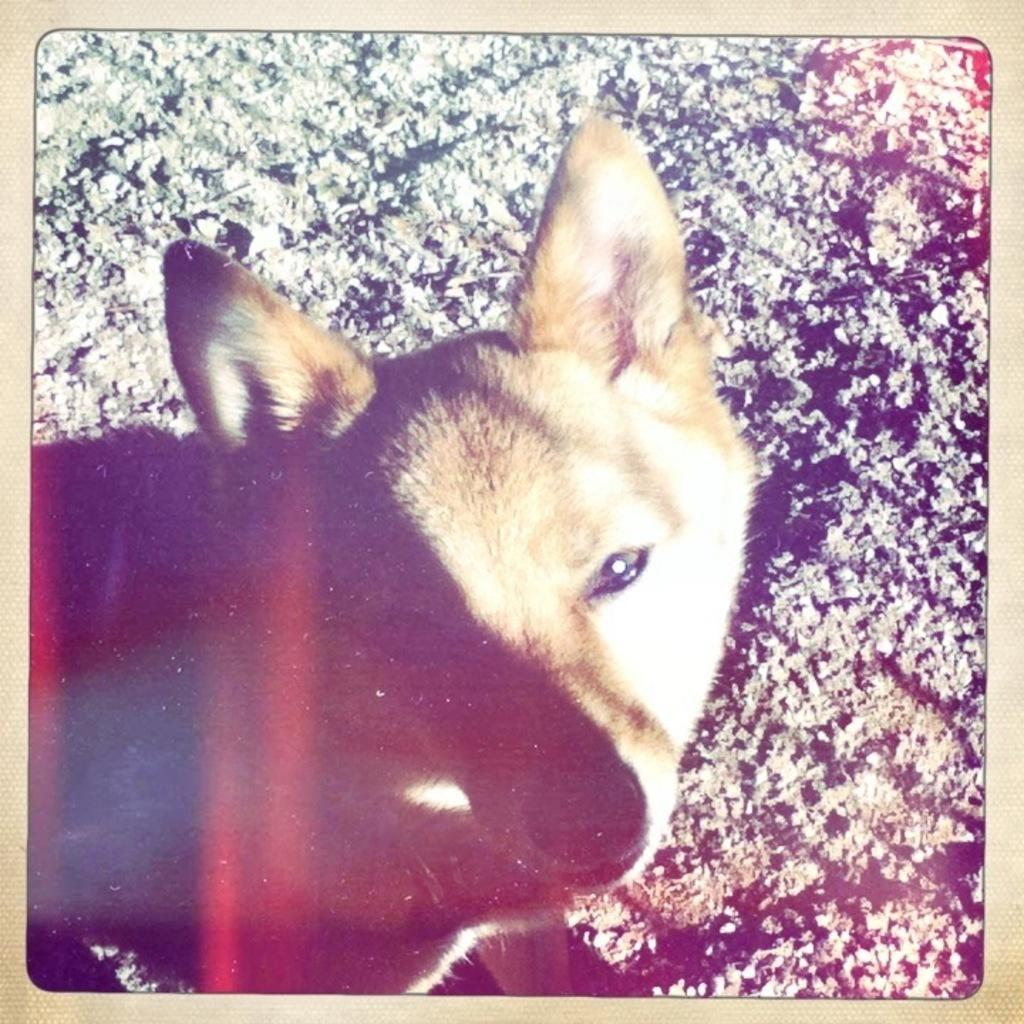What is displayed on the page of the album in the image? There is a photograph on a page of an album. What can be seen in the photograph? The photograph contains an image of a dog. What is visible on the ground in the photograph? There are stones on the ground in the photograph. What type of heart-shaped plate is visible in the image? There is no heart-shaped plate present in the image. What boundary is depicted in the image? The image does not show any boundaries; it contains a photograph of a dog and stones on the ground. 